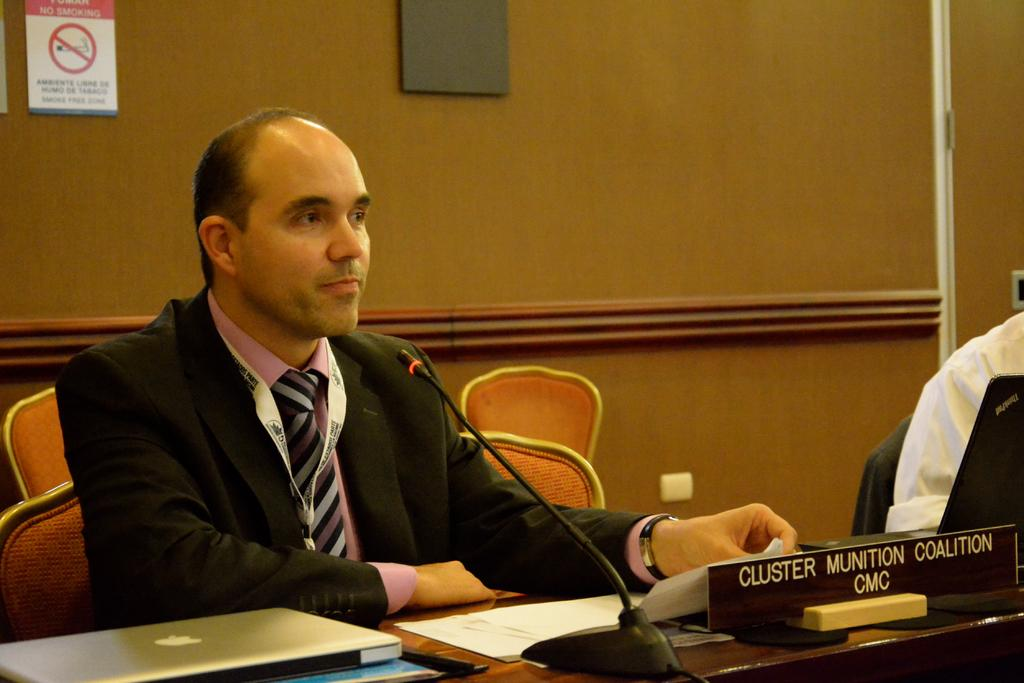What electronic device is on the table in the image? There is a laptop on a table in the image. What other object is on the table? There is a microphone and papers on the table. What is the person in the image wearing? The person is wearing a suit. What can be seen on the wall behind the person? There is a sign board on the wall behind the person. Can you see any feathers on the person's suit in the image? There are no feathers visible on the person's suit in the image. What type of match is being used by the person in the image? There is no match present in the image; the person is not using any matches. 